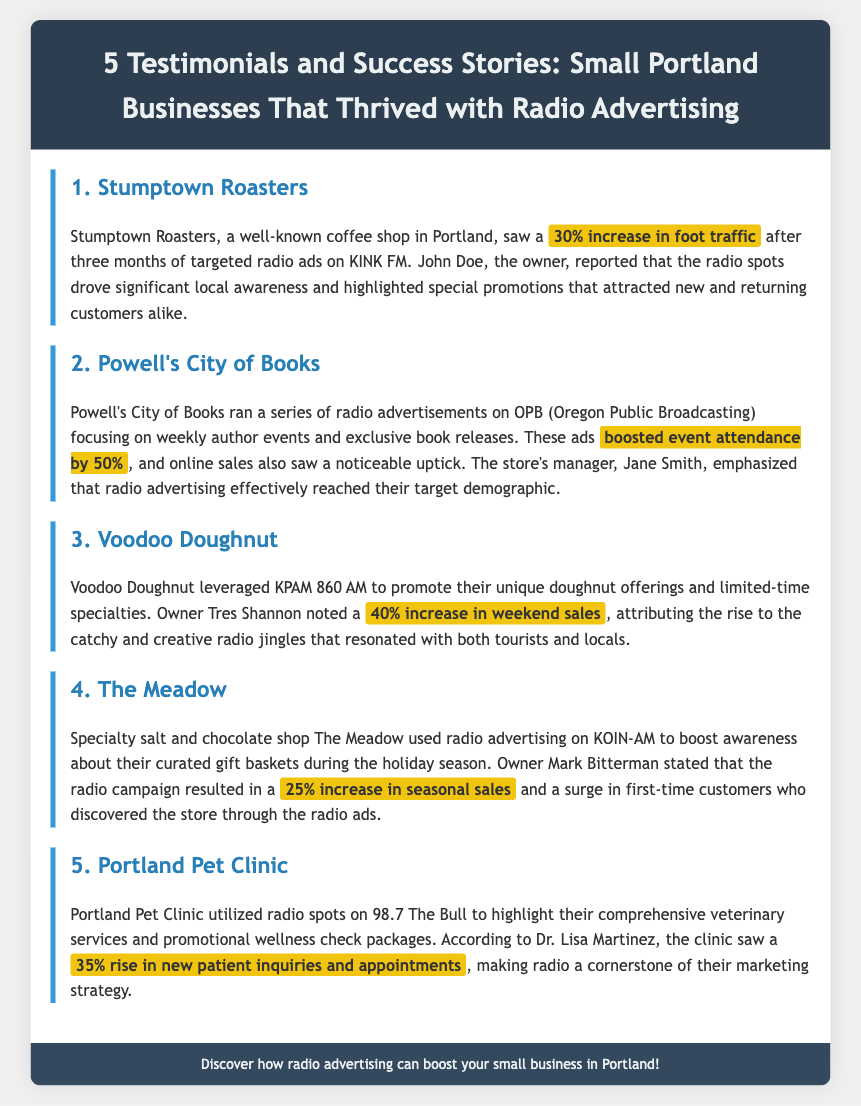What business saw a 30% increase in foot traffic? Stumptown Roasters reported a 30% increase in foot traffic due to their radio advertising efforts.
Answer: Stumptown Roasters Which radio station did Powell's City of Books advertise on? Powell's City of Books ran radio advertisements on OPB (Oregon Public Broadcasting).
Answer: OPB What percentage increase in weekend sales did Voodoo Doughnut experience? Voodoo Doughnut noted a 40% increase in weekend sales attributed to their radio campaign.
Answer: 40% How much did The Meadow's seasonal sales increase? The Meadow experienced a 25% increase in seasonal sales as a result of their radio advertising.
Answer: 25% What is the primary demographic that radio advertising effectively reached for Powell's? Jane Smith emphasized that radio advertising effectively reached their target demographic.
Answer: Target demographic Which business highlighted their veterinary services on 98.7 The Bull? Portland Pet Clinic utilized radio spots on 98.7 The Bull to promote their services.
Answer: Portland Pet Clinic Who is the owner of Voodoo Doughnut? The owner of Voodoo Doughnut is Tres Shannon, who reported the sales increase due to radio advertising.
Answer: Tres Shannon How long did Stumptown Roasters run their radio ads? Stumptown Roasters saw a 30% increase in foot traffic after three months of targeted radio ads.
Answer: Three months What type of promotional packages did Portland Pet Clinic advertise? Portland Pet Clinic highlighted their promotional wellness check packages in their ads.
Answer: Wellness check packages 